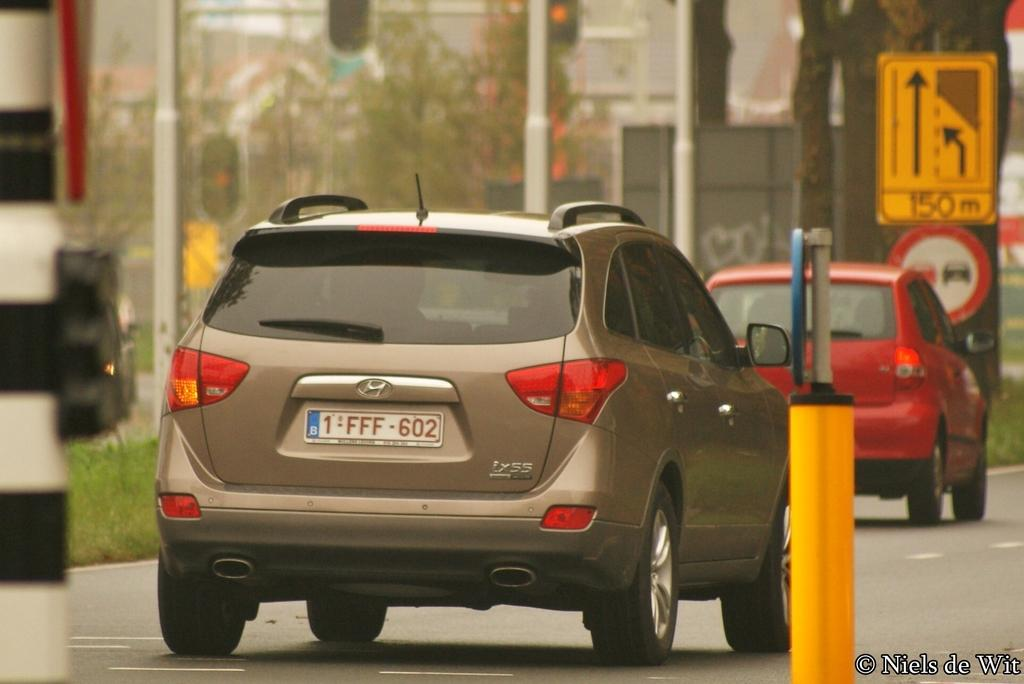What is happening in the image? There are cars on a road in the image. What can be seen in the background of the image? There are poles, trees, and boards in the background of the image. How is the background of the image depicted? The background is blurred. Is there any text present in the image? Yes, there is text in the bottom right corner of the image. What type of business is being conducted on the channel in the image? There is no channel or business present in the image; it features cars on a road with a blurred background. 